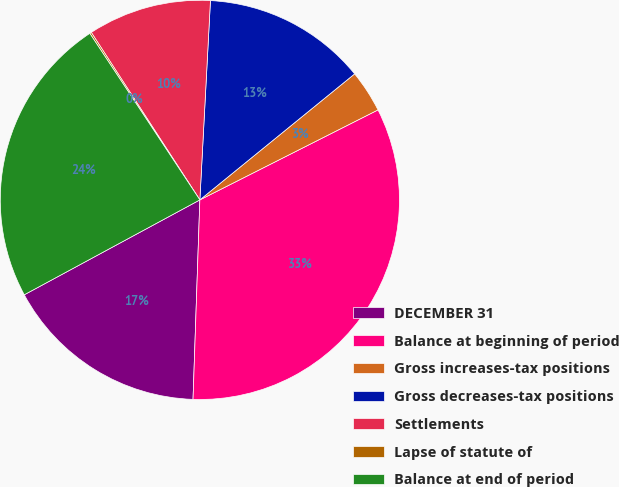<chart> <loc_0><loc_0><loc_500><loc_500><pie_chart><fcel>DECEMBER 31<fcel>Balance at beginning of period<fcel>Gross increases-tax positions<fcel>Gross decreases-tax positions<fcel>Settlements<fcel>Lapse of statute of<fcel>Balance at end of period<nl><fcel>16.57%<fcel>32.99%<fcel>3.43%<fcel>13.28%<fcel>10.0%<fcel>0.14%<fcel>23.59%<nl></chart> 